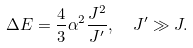<formula> <loc_0><loc_0><loc_500><loc_500>\Delta E = \frac { 4 } { 3 } \alpha ^ { 2 } \frac { J ^ { 2 } } { J ^ { \prime } } , \ \ J ^ { \prime } \gg J .</formula> 